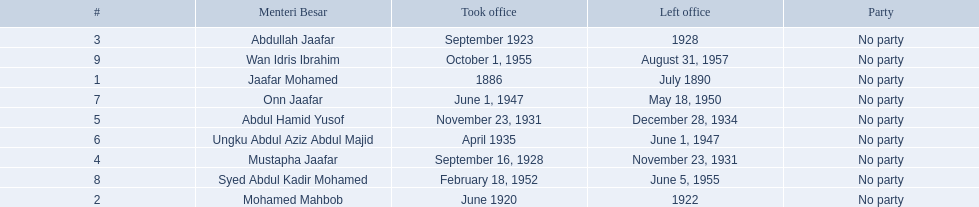When did jaafar mohamed take office? 1886. When did mohamed mahbob take office? June 1920. Who was in office no more than 4 years? Mohamed Mahbob. 